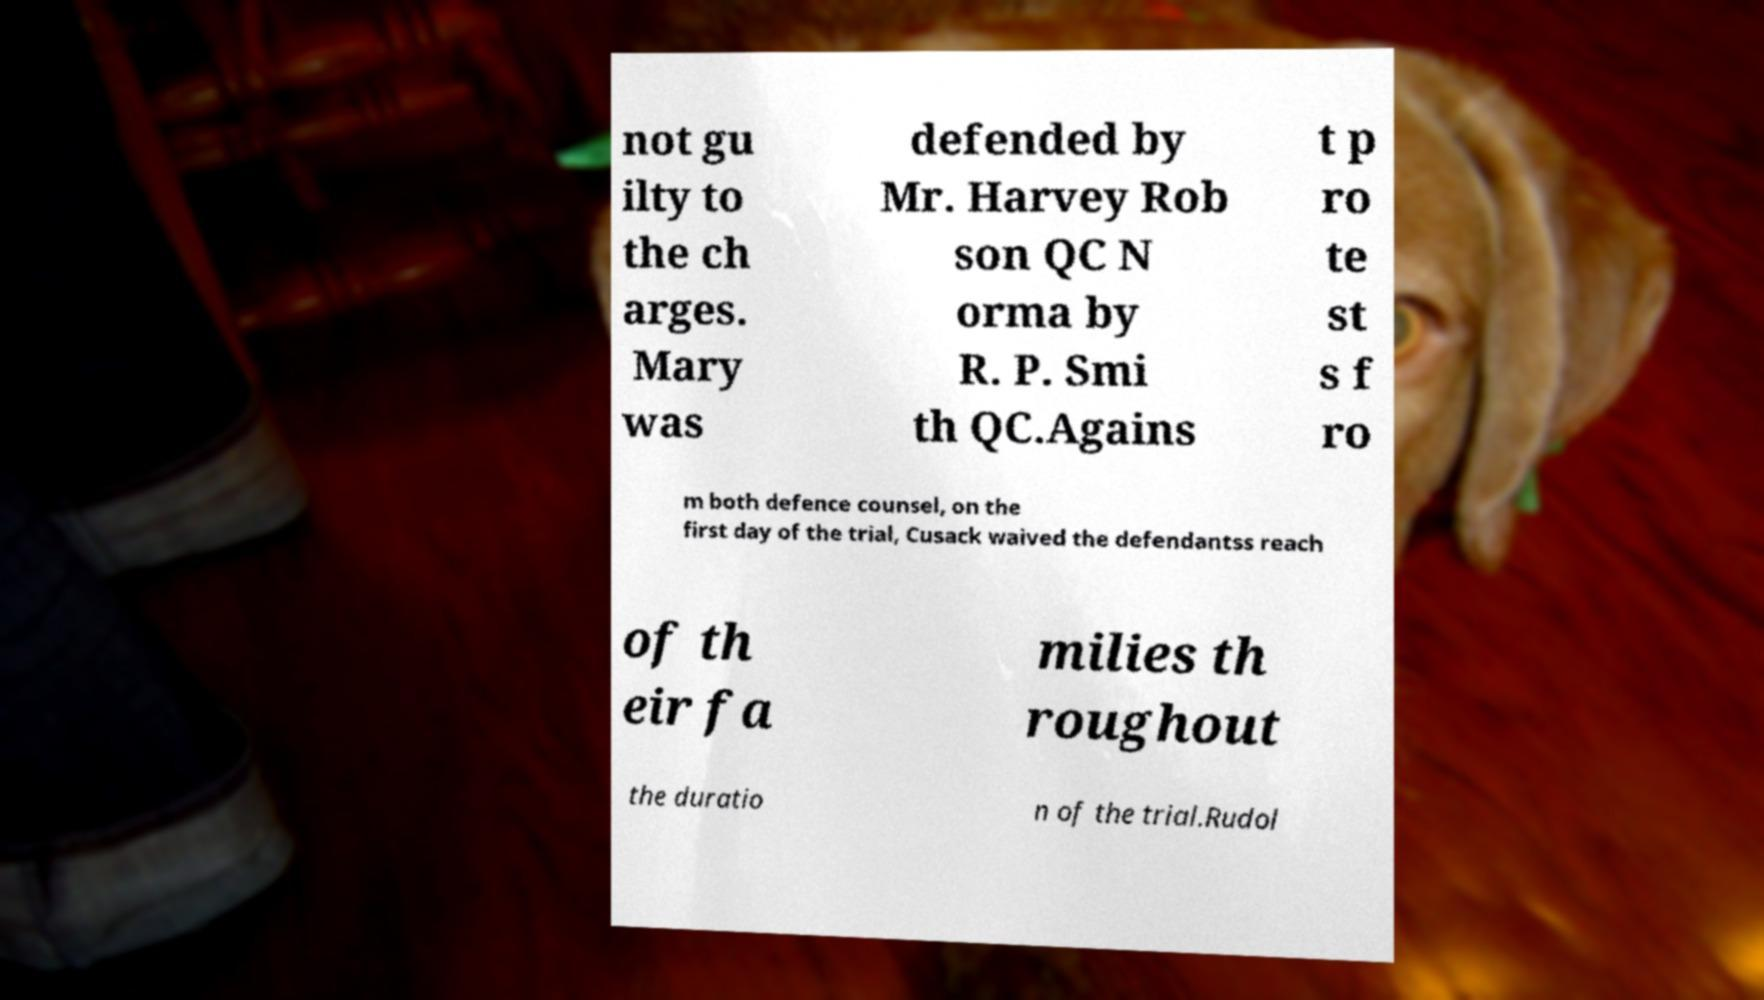Can you accurately transcribe the text from the provided image for me? not gu ilty to the ch arges. Mary was defended by Mr. Harvey Rob son QC N orma by R. P. Smi th QC.Agains t p ro te st s f ro m both defence counsel, on the first day of the trial, Cusack waived the defendantss reach of th eir fa milies th roughout the duratio n of the trial.Rudol 